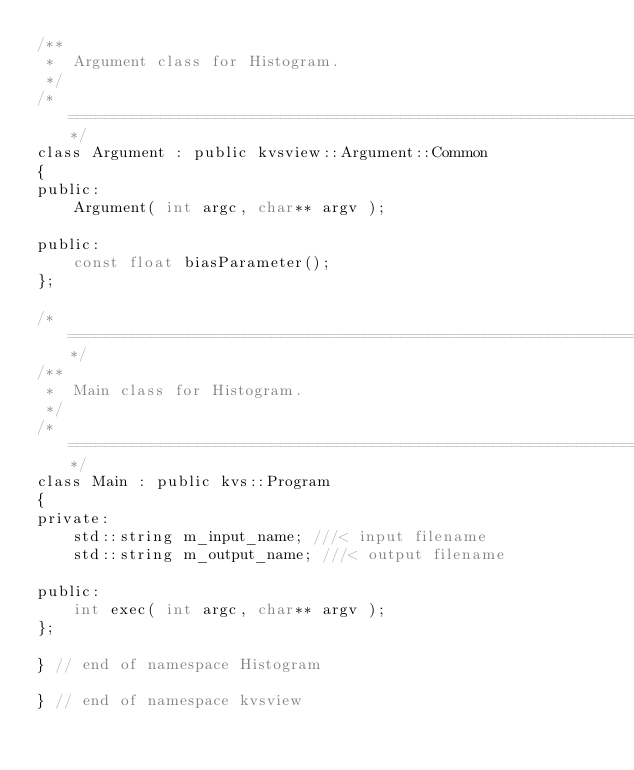<code> <loc_0><loc_0><loc_500><loc_500><_C_>/**
 *  Argument class for Histogram.
 */
/*===========================================================================*/
class Argument : public kvsview::Argument::Common
{
public:
    Argument( int argc, char** argv );

public:
    const float biasParameter();
};

/*===========================================================================*/
/**
 *  Main class for Histogram.
 */
/*===========================================================================*/
class Main : public kvs::Program
{
private:
    std::string m_input_name; ///< input filename
    std::string m_output_name; ///< output filename

public:
    int exec( int argc, char** argv );
};

} // end of namespace Histogram

} // end of namespace kvsview
</code> 